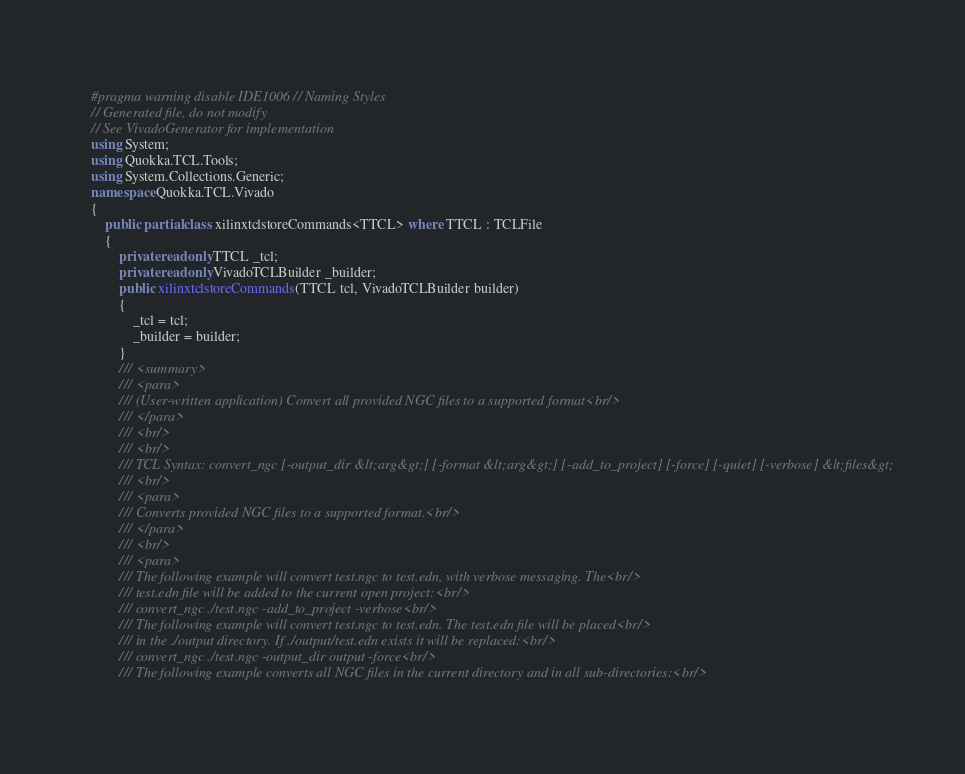Convert code to text. <code><loc_0><loc_0><loc_500><loc_500><_C#_>#pragma warning disable IDE1006 // Naming Styles
// Generated file, do not modify
// See VivadoGenerator for implementation
using System;
using Quokka.TCL.Tools;
using System.Collections.Generic;
namespace Quokka.TCL.Vivado
{
	public partial class xilinxtclstoreCommands<TTCL> where TTCL : TCLFile
	{
		private readonly TTCL _tcl;
		private readonly VivadoTCLBuilder _builder;
		public xilinxtclstoreCommands(TTCL tcl, VivadoTCLBuilder builder)
		{
			_tcl = tcl;
			_builder = builder;
		}
		/// <summary>
		/// <para>
		/// (User-written application) Convert all provided NGC files to a supported format<br/>
		/// </para>
		/// <br/>
		/// <br/>
		/// TCL Syntax: convert_ngc [-output_dir &lt;arg&gt;] [-format &lt;arg&gt;] [-add_to_project] [-force] [-quiet] [-verbose] &lt;files&gt;
		/// <br/>
		/// <para>
		/// Converts provided NGC files to a supported format.<br/>
		/// </para>
		/// <br/>
		/// <para>
		/// The following example will convert test.ngc to test.edn, with verbose messaging. The<br/>
		/// test.edn file will be added to the current open project:<br/>
		/// convert_ngc ./test.ngc -add_to_project -verbose<br/>
		/// The following example will convert test.ngc to test.edn. The test.edn file will be placed<br/>
		/// in the ./output directory. If ./output/test.edn exists it will be replaced:<br/>
		/// convert_ngc ./test.ngc -output_dir output -force<br/>
		/// The following example converts all NGC files in the current directory and in all sub-directories:<br/></code> 